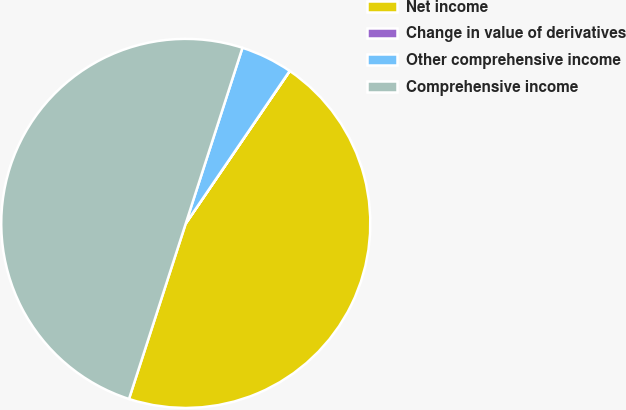Convert chart to OTSL. <chart><loc_0><loc_0><loc_500><loc_500><pie_chart><fcel>Net income<fcel>Change in value of derivatives<fcel>Other comprehensive income<fcel>Comprehensive income<nl><fcel>45.45%<fcel>0.01%<fcel>4.55%<fcel>49.99%<nl></chart> 